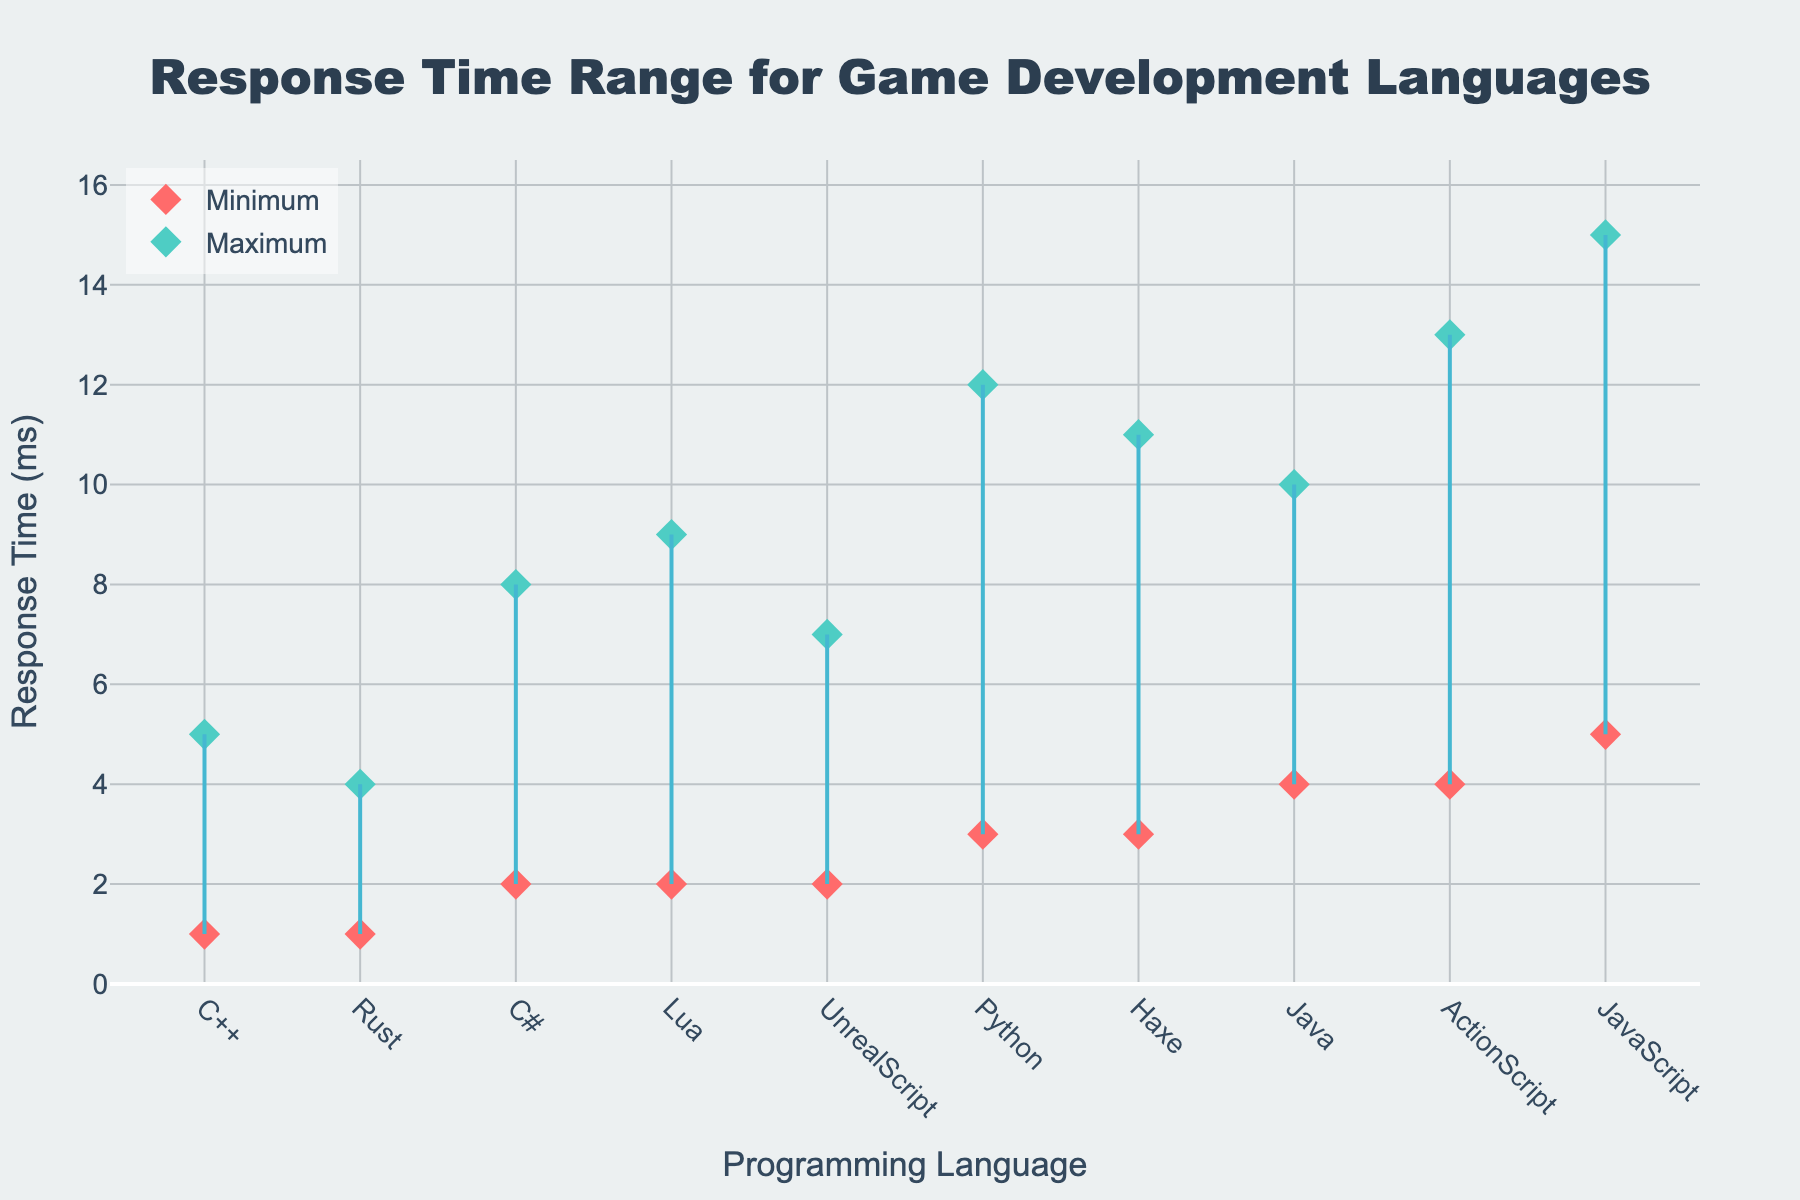What is the title of the plot? The title of the plot is prominently displayed at the top and can be directly read.
Answer: Response Time Range for Game Development Languages Which programming language has the lowest minimum response time? By examining the plot, the programming language with the lowest position on the y-axis for the minimum response time marker can be identified.
Answer: C++ and Rust What is the maximum response time for JavaScript? Locate JavaScript on the x-axis and identify the position of the maximum response time marker along the y-axis.
Answer: 15 ms Which programming language has the widest range of response times? To determine which language has the widest range, find the language whose min and max response time markers are the furthest apart.
Answer: JavaScript Are there any programming languages with the same minimum response time? Look at the markers for min response times and see if any share the same y-axis position.
Answer: Yes, C# and Lua What is the average of the minimum response times for Python and Haxe? Get the minimum response times for Python (3 ms) and Haxe (3 ms), sum them (3+3=6), and then divide by 2.
Answer: 3 ms Which languages have a maximum response time greater than 10 ms? Identify languages with their maximum response time markers above the 10 ms line on the y-axis.
Answer: Python, JavaScript, ActionScript, Haxe How many programming languages have a minimum response time below 3 ms? Count the languages whose minimum response time markers are below the 3 ms line on the y-axis.
Answer: Three languages (C++, Rust, and UnrealScript) What is the difference in maximum response time between C# and Java? Subtract the maximum response time of Java (10 ms) from that of C# (8 ms).
Answer: 2 ms Which programming language has the smallest difference between its minimum and maximum response times? Find the language where the vertical line connecting min and max markers is shortest.
Answer: Rust 